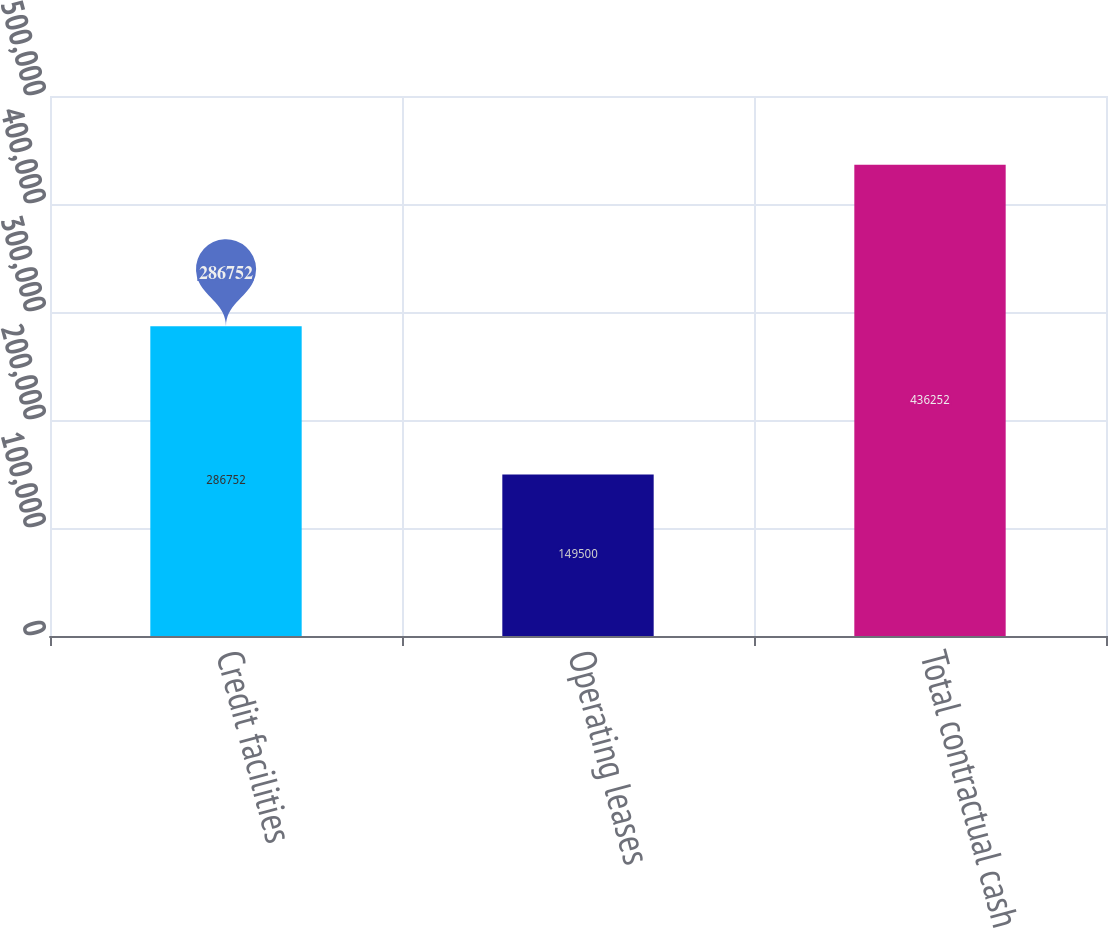Convert chart. <chart><loc_0><loc_0><loc_500><loc_500><bar_chart><fcel>Credit facilities<fcel>Operating leases<fcel>Total contractual cash<nl><fcel>286752<fcel>149500<fcel>436252<nl></chart> 